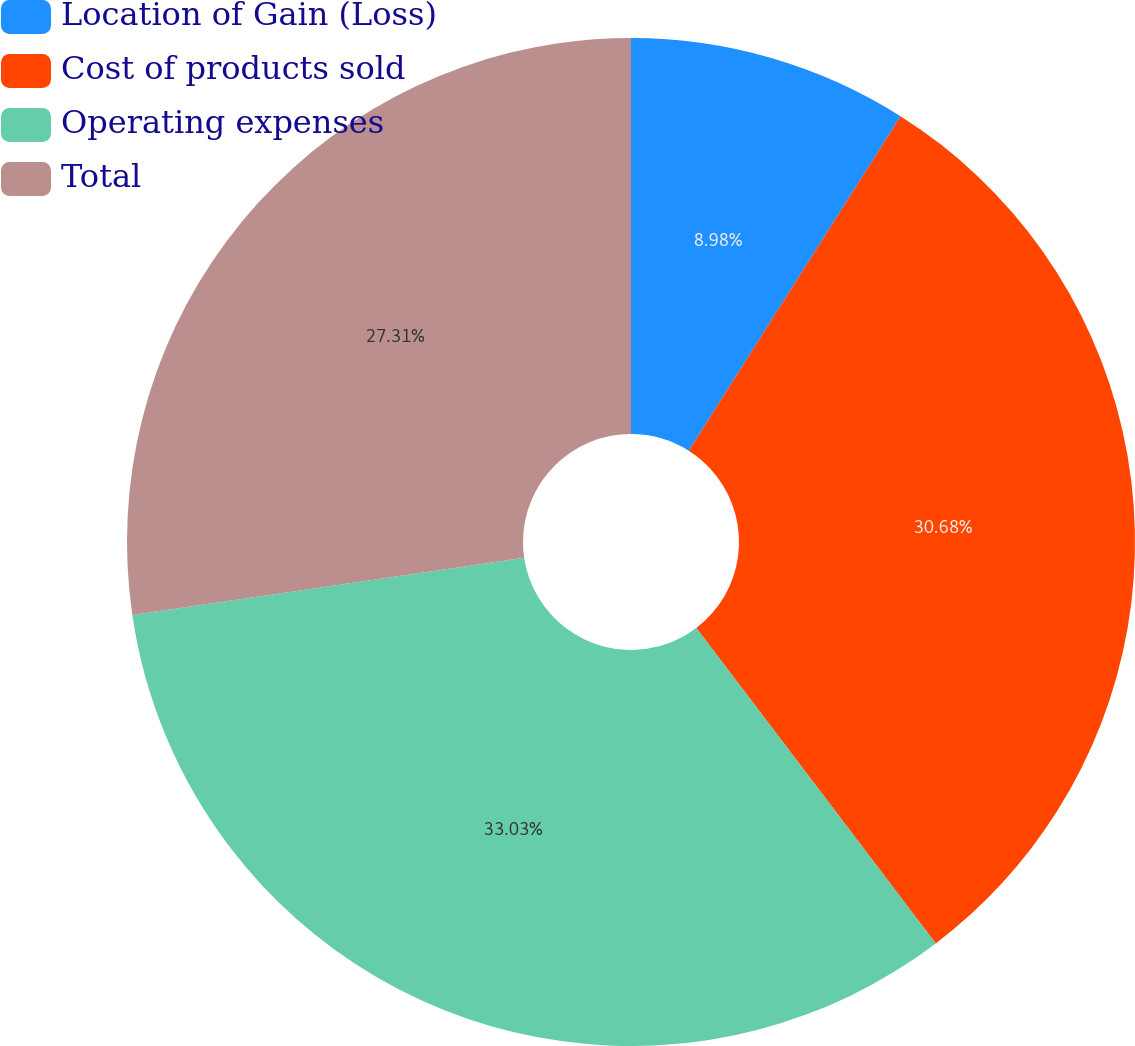<chart> <loc_0><loc_0><loc_500><loc_500><pie_chart><fcel>Location of Gain (Loss)<fcel>Cost of products sold<fcel>Operating expenses<fcel>Total<nl><fcel>8.98%<fcel>30.68%<fcel>33.02%<fcel>27.31%<nl></chart> 